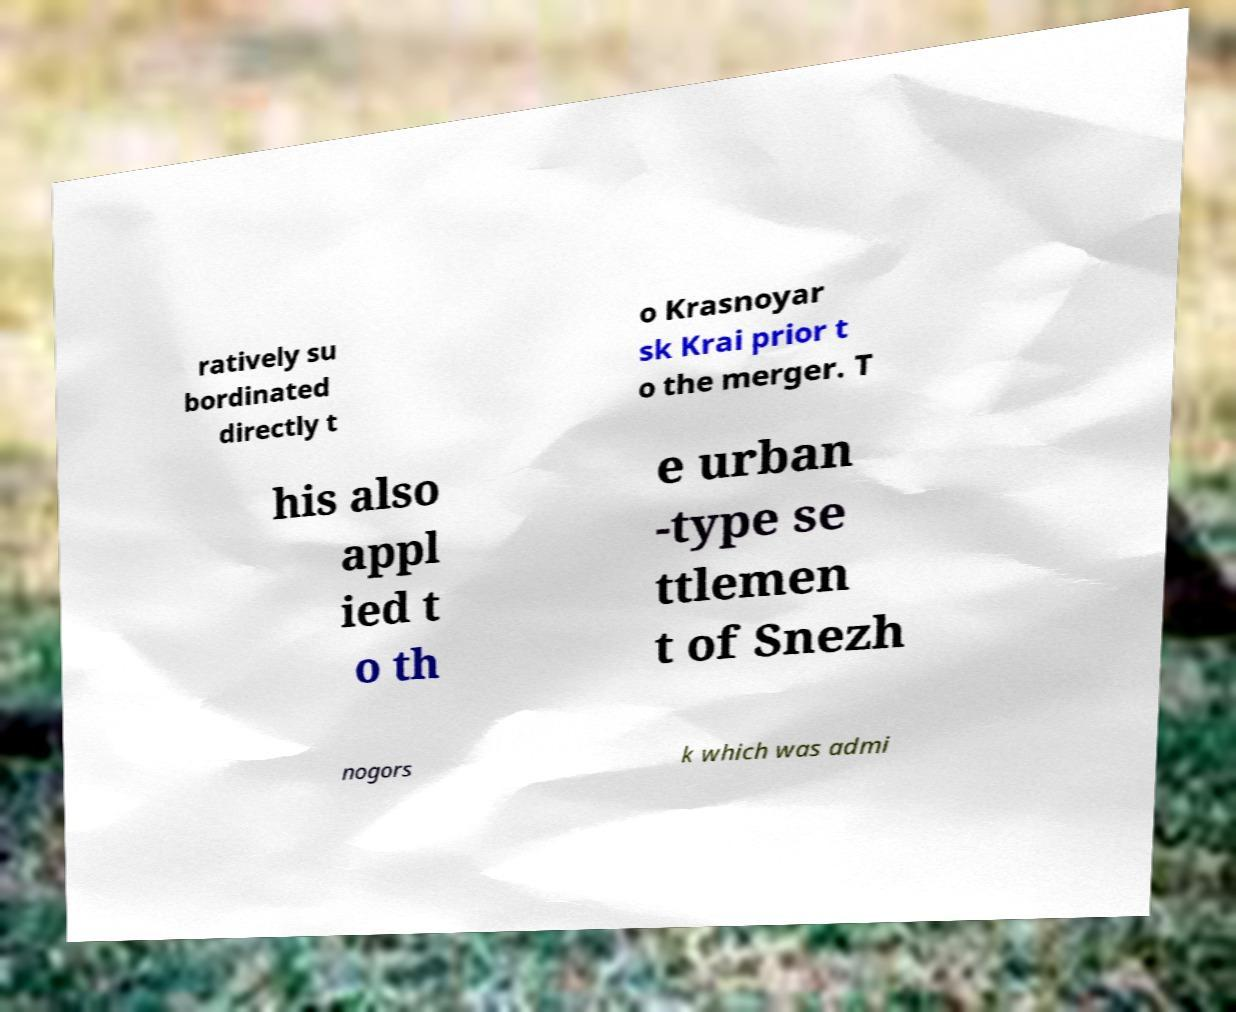Could you extract and type out the text from this image? ratively su bordinated directly t o Krasnoyar sk Krai prior t o the merger. T his also appl ied t o th e urban -type se ttlemen t of Snezh nogors k which was admi 